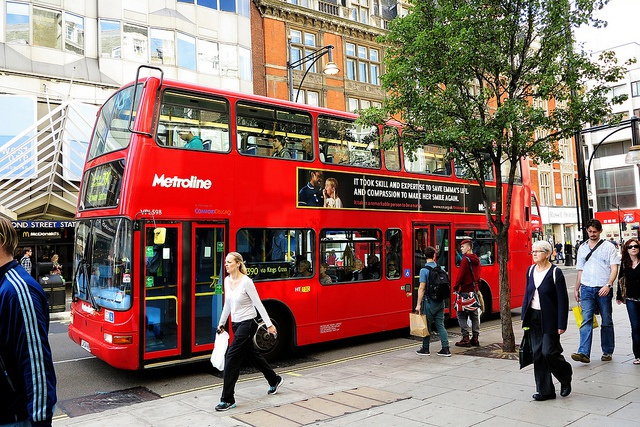Describe the objects in this image and their specific colors. I can see bus in white, black, red, and brown tones, people in white, black, navy, gray, and lightblue tones, people in white, black, navy, and darkgray tones, people in white, black, lightgray, darkgray, and gray tones, and people in white, lavender, black, navy, and darkgray tones in this image. 